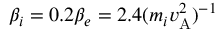Convert formula to latex. <formula><loc_0><loc_0><loc_500><loc_500>\beta _ { i } = 0 . 2 \beta _ { e } = 2 . 4 ( m _ { i } v _ { A } ^ { 2 } ) ^ { - 1 }</formula> 